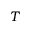<formula> <loc_0><loc_0><loc_500><loc_500>T</formula> 